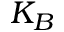Convert formula to latex. <formula><loc_0><loc_0><loc_500><loc_500>K _ { B }</formula> 